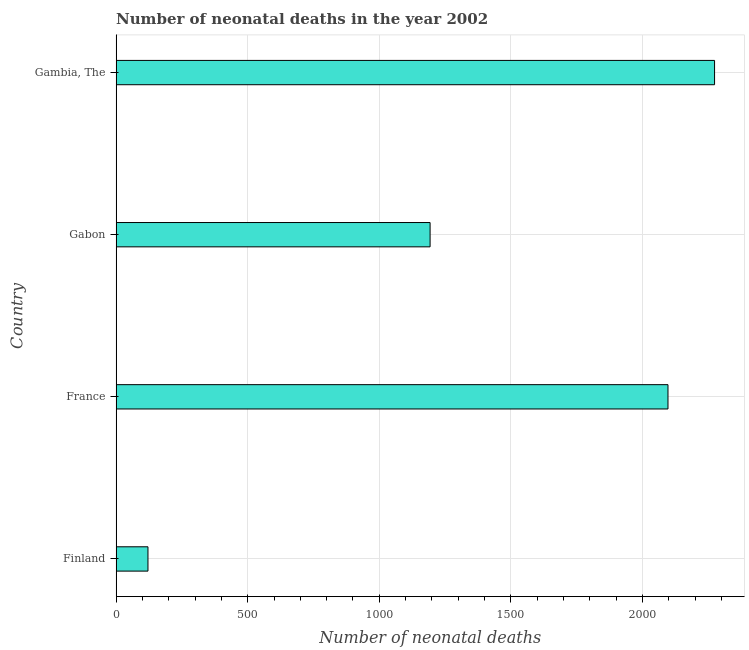Does the graph contain any zero values?
Give a very brief answer. No. Does the graph contain grids?
Keep it short and to the point. Yes. What is the title of the graph?
Your answer should be very brief. Number of neonatal deaths in the year 2002. What is the label or title of the X-axis?
Give a very brief answer. Number of neonatal deaths. What is the number of neonatal deaths in Gabon?
Provide a succinct answer. 1193. Across all countries, what is the maximum number of neonatal deaths?
Ensure brevity in your answer.  2274. Across all countries, what is the minimum number of neonatal deaths?
Provide a succinct answer. 121. In which country was the number of neonatal deaths maximum?
Your answer should be compact. Gambia, The. What is the sum of the number of neonatal deaths?
Offer a very short reply. 5685. What is the difference between the number of neonatal deaths in Finland and Gambia, The?
Offer a terse response. -2153. What is the average number of neonatal deaths per country?
Offer a terse response. 1421. What is the median number of neonatal deaths?
Offer a very short reply. 1645. In how many countries, is the number of neonatal deaths greater than 300 ?
Provide a short and direct response. 3. What is the ratio of the number of neonatal deaths in France to that in Gambia, The?
Provide a succinct answer. 0.92. What is the difference between the highest and the second highest number of neonatal deaths?
Offer a terse response. 177. What is the difference between the highest and the lowest number of neonatal deaths?
Offer a very short reply. 2153. In how many countries, is the number of neonatal deaths greater than the average number of neonatal deaths taken over all countries?
Keep it short and to the point. 2. How many bars are there?
Your answer should be compact. 4. How many countries are there in the graph?
Provide a short and direct response. 4. What is the difference between two consecutive major ticks on the X-axis?
Your answer should be very brief. 500. What is the Number of neonatal deaths in Finland?
Offer a terse response. 121. What is the Number of neonatal deaths of France?
Offer a very short reply. 2097. What is the Number of neonatal deaths in Gabon?
Your answer should be very brief. 1193. What is the Number of neonatal deaths in Gambia, The?
Make the answer very short. 2274. What is the difference between the Number of neonatal deaths in Finland and France?
Provide a succinct answer. -1976. What is the difference between the Number of neonatal deaths in Finland and Gabon?
Your answer should be very brief. -1072. What is the difference between the Number of neonatal deaths in Finland and Gambia, The?
Ensure brevity in your answer.  -2153. What is the difference between the Number of neonatal deaths in France and Gabon?
Offer a terse response. 904. What is the difference between the Number of neonatal deaths in France and Gambia, The?
Give a very brief answer. -177. What is the difference between the Number of neonatal deaths in Gabon and Gambia, The?
Your response must be concise. -1081. What is the ratio of the Number of neonatal deaths in Finland to that in France?
Provide a short and direct response. 0.06. What is the ratio of the Number of neonatal deaths in Finland to that in Gabon?
Make the answer very short. 0.1. What is the ratio of the Number of neonatal deaths in Finland to that in Gambia, The?
Provide a short and direct response. 0.05. What is the ratio of the Number of neonatal deaths in France to that in Gabon?
Make the answer very short. 1.76. What is the ratio of the Number of neonatal deaths in France to that in Gambia, The?
Your answer should be compact. 0.92. What is the ratio of the Number of neonatal deaths in Gabon to that in Gambia, The?
Keep it short and to the point. 0.53. 